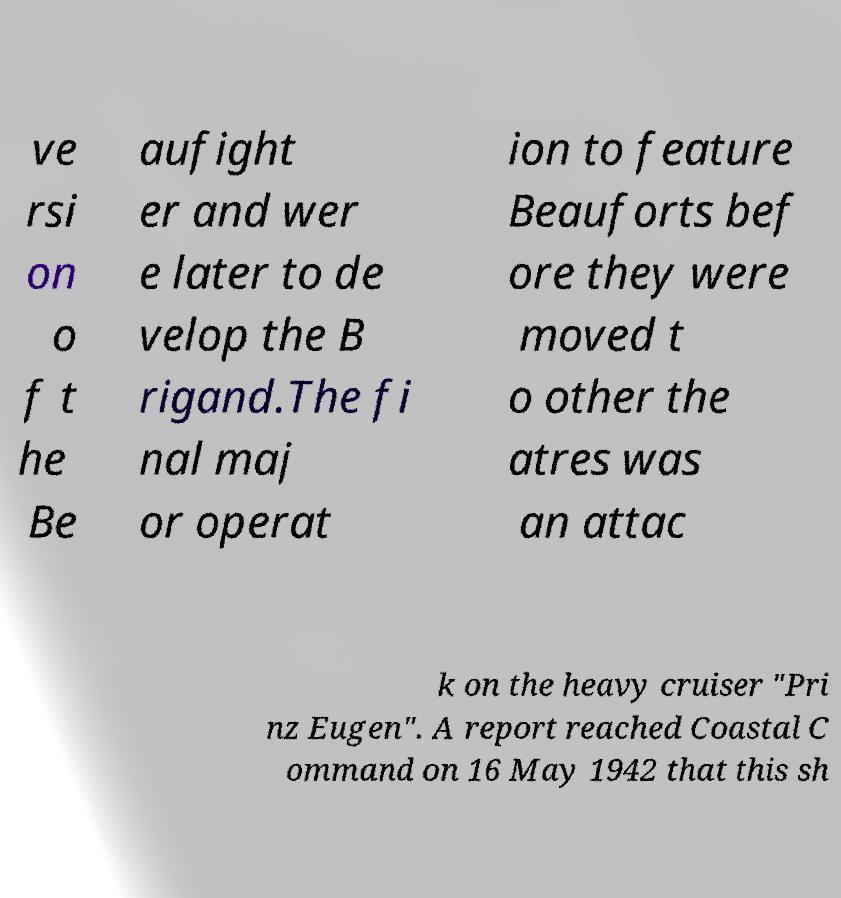Could you extract and type out the text from this image? ve rsi on o f t he Be aufight er and wer e later to de velop the B rigand.The fi nal maj or operat ion to feature Beauforts bef ore they were moved t o other the atres was an attac k on the heavy cruiser "Pri nz Eugen". A report reached Coastal C ommand on 16 May 1942 that this sh 